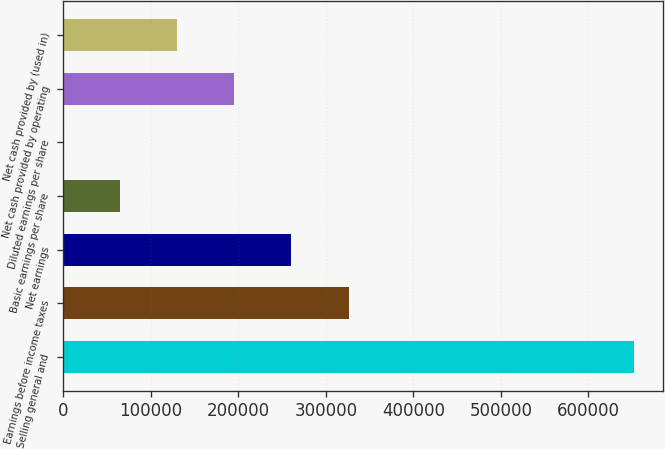<chart> <loc_0><loc_0><loc_500><loc_500><bar_chart><fcel>Selling general and<fcel>Earnings before income taxes<fcel>Net earnings<fcel>Basic earnings per share<fcel>Diluted earnings per share<fcel>Net cash provided by operating<fcel>Net cash provided by (used in)<nl><fcel>651988<fcel>325994<fcel>260796<fcel>65199.4<fcel>0.7<fcel>195597<fcel>130398<nl></chart> 